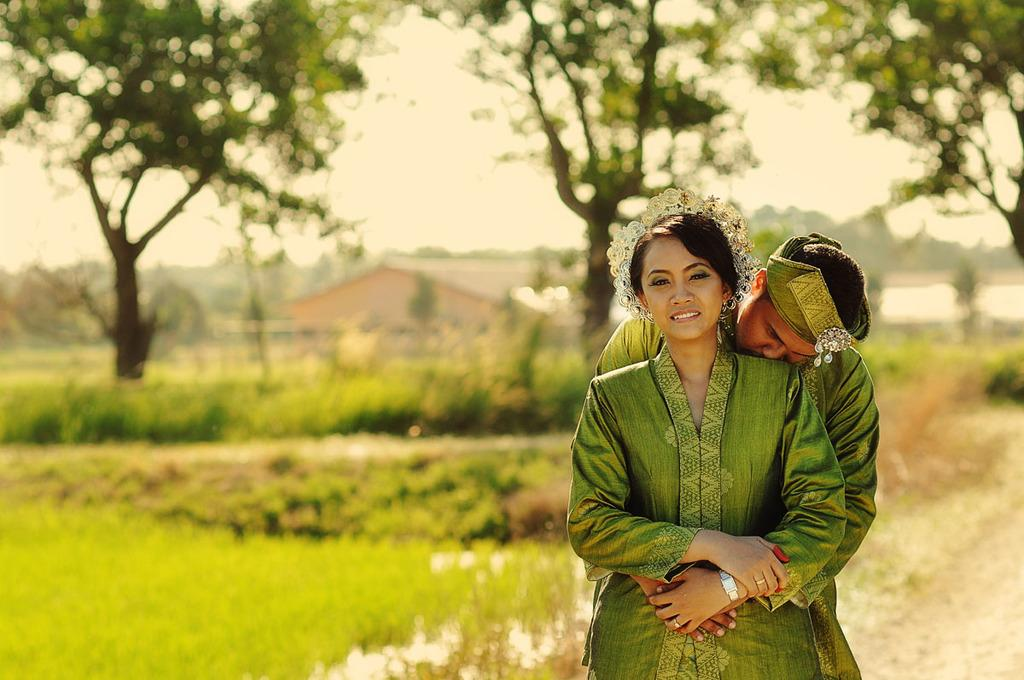Who are the people in the image? There is a man and a woman in the image. What are the people in the image doing? They are both standing. What color clothes are the people in the image wearing? They are both wearing green clothes. What can be seen in the background of the image? There are trees, plants, buildings, and the sky visible in the background of the image. How many mice are visible on the man's face in the image? There are no mice visible on the man's face in the image. What type of nail is being used by the woman in the image? There is no nail being used by the woman in the image. 